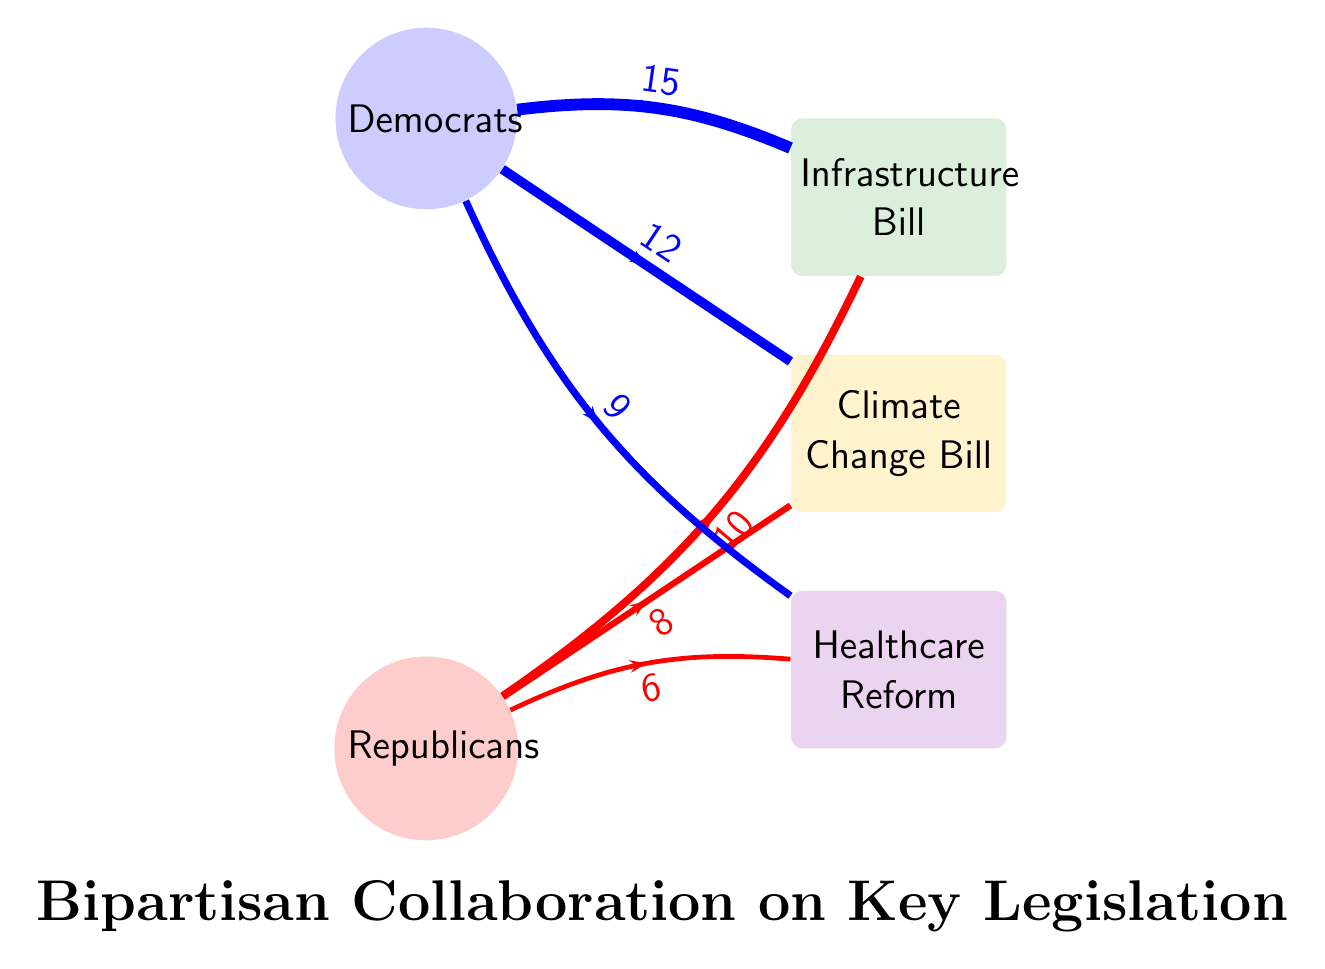What is the total number of votes from Democrats on the Infrastructure Bill? The Democrats contributed 15 votes to the Infrastructure Bill as shown by the link connecting them.
Answer: 15 How many votes do Republicans contribute to the Climate Change Bill? The Republicans contributed 8 votes to the Climate Change Bill, represented by the link from Republicans to Climate Change Bill in the diagram.
Answer: 8 Which bill received the most bipartisan support? The Infrastructure Bill received a total of 25 votes (15 from Democrats and 10 from Republicans), making it the bill with the most bipartisan support.
Answer: Infrastructure Bill How many total nodes are present in the diagram? The diagram contains a total of 5 nodes: 2 parties (Democrats and Republicans) and 3 bills (Infrastructure Bill, Climate Change Bill, and Healthcare Reform).
Answer: 5 What is the difference in votes between Democrats and Republicans for the Healthcare Reform? Democrats contributed 9 votes and Republicans contributed 6 votes, creating a difference of 3 votes in favor of Democrats for the Healthcare Reform.
Answer: 3 How many total votes were cast by Republicans across all bills? Adding the votes for Republicans across all bills: 10 (Infrastructure) + 8 (Climate Change) + 6 (Healthcare Reform) results in a total of 24 votes cast by Republicans.
Answer: 24 What color represents the Healthcare Reform in the diagram? The Healthcare Reform bill is represented using a purple color, as dictated by its unique color code in the diagram.
Answer: Purple Which party contributed to all three pieces of legislation shown in the diagram? The Democrats contributed votes to all three major bills: 15 for Infrastructure, 12 for Climate Change, and 9 for Healthcare Reform.
Answer: Democrats 